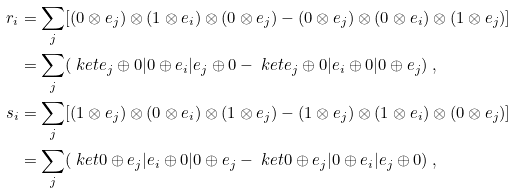Convert formula to latex. <formula><loc_0><loc_0><loc_500><loc_500>r _ { i } & = \sum _ { j } [ ( 0 \otimes e _ { j } ) \otimes ( 1 \otimes e _ { i } ) \otimes ( 0 \otimes e _ { j } ) - ( 0 \otimes e _ { j } ) \otimes ( 0 \otimes e _ { i } ) \otimes ( 1 \otimes e _ { j } ) ] \\ & = \sum _ { j } ( \ k e t { e _ { j } \oplus 0 | 0 \oplus e _ { i } | e _ { j } \oplus 0 } - \ k e t { e _ { j } \oplus 0 | e _ { i } \oplus 0 | 0 \oplus e _ { j } } ) \ , \\ s _ { i } & = \sum _ { j } [ ( 1 \otimes e _ { j } ) \otimes ( 0 \otimes e _ { i } ) \otimes ( 1 \otimes e _ { j } ) - ( 1 \otimes e _ { j } ) \otimes ( 1 \otimes e _ { i } ) \otimes ( 0 \otimes e _ { j } ) ] \\ & = \sum _ { j } ( \ k e t { 0 \oplus e _ { j } | e _ { i } \oplus 0 | 0 \oplus e _ { j } } - \ k e t { 0 \oplus e _ { j } | 0 \oplus e _ { i } | e _ { j } \oplus 0 } ) \ ,</formula> 